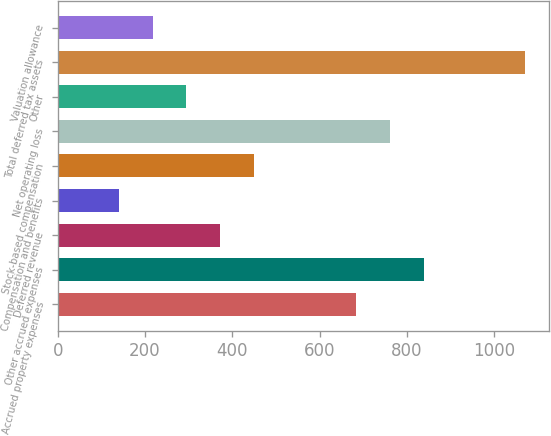<chart> <loc_0><loc_0><loc_500><loc_500><bar_chart><fcel>Accrued property expenses<fcel>Other accrued expenses<fcel>Deferred revenue<fcel>Compensation and benefits<fcel>Stock-based compensation<fcel>Net operating loss<fcel>Other<fcel>Total deferred tax assets<fcel>Valuation allowance<nl><fcel>682.8<fcel>838<fcel>372.4<fcel>139.6<fcel>450<fcel>760.4<fcel>294.8<fcel>1070.8<fcel>217.2<nl></chart> 